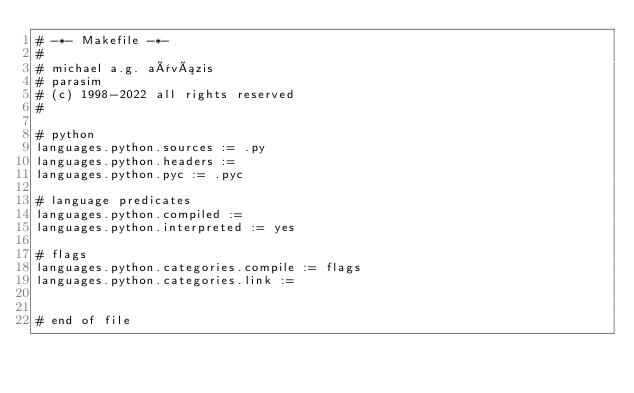Convert code to text. <code><loc_0><loc_0><loc_500><loc_500><_ObjectiveC_># -*- Makefile -*-
#
# michael a.g. aïvázis
# parasim
# (c) 1998-2022 all rights reserved
#

# python
languages.python.sources := .py
languages.python.headers :=
languages.python.pyc := .pyc

# language predicates
languages.python.compiled :=
languages.python.interpreted := yes

# flags
languages.python.categories.compile := flags
languages.python.categories.link :=


# end of file
</code> 